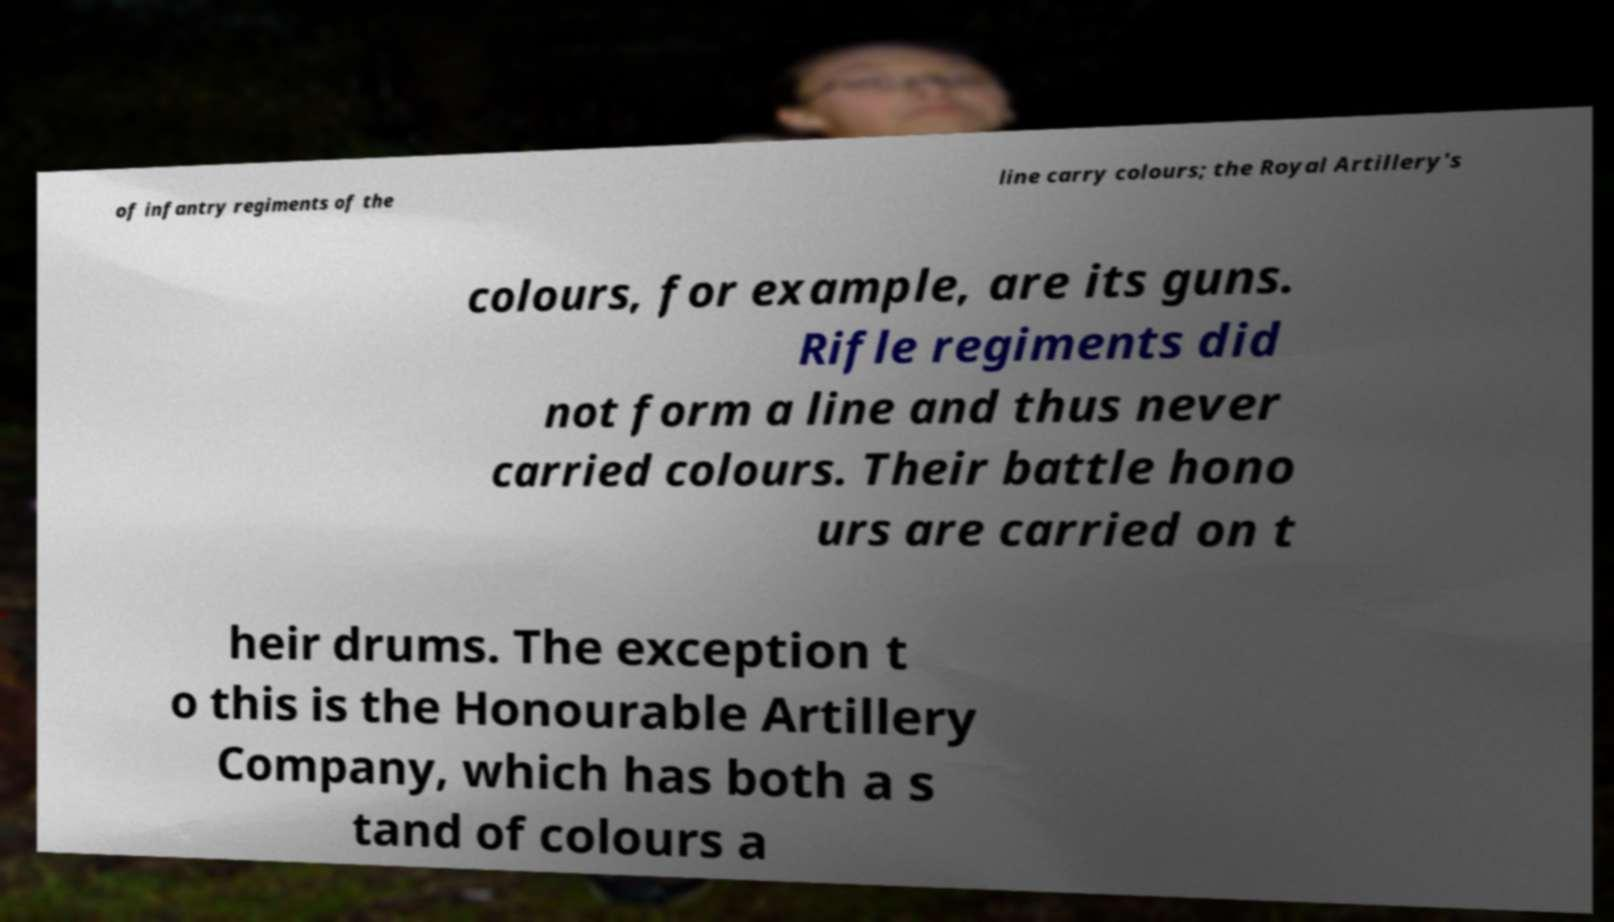What messages or text are displayed in this image? I need them in a readable, typed format. of infantry regiments of the line carry colours; the Royal Artillery's colours, for example, are its guns. Rifle regiments did not form a line and thus never carried colours. Their battle hono urs are carried on t heir drums. The exception t o this is the Honourable Artillery Company, which has both a s tand of colours a 